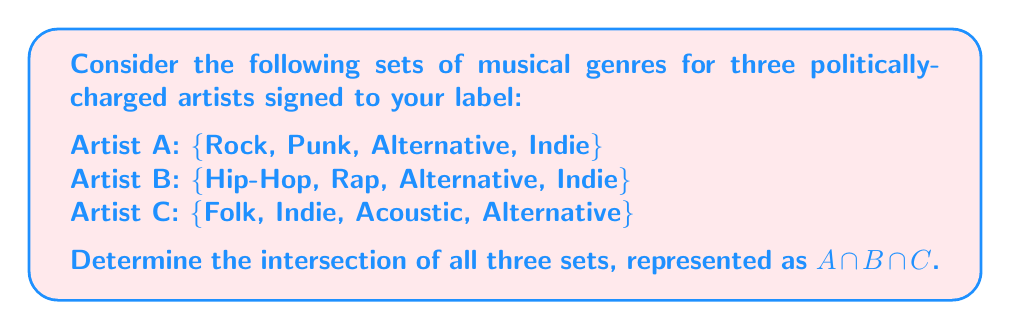Teach me how to tackle this problem. To find the intersection of all three sets, we need to identify the elements that are common to all three sets. Let's approach this step-by-step:

1. First, let's list out each set:
   Set A = $\{$Rock, Punk, Alternative, Indie$\}$
   Set B = $\{$Hip-Hop, Rap, Alternative, Indie$\}$
   Set C = $\{$Folk, Indie, Acoustic, Alternative$\}$

2. Now, we need to find elements that appear in all three sets. We can do this by comparing the elements:

   - "Rock" is only in Set A
   - "Punk" is only in Set A
   - "Hip-Hop" is only in Set B
   - "Rap" is only in Set B
   - "Folk" is only in Set C
   - "Acoustic" is only in Set C
   - "Alternative" appears in all three sets
   - "Indie" appears in all three sets

3. The intersection of all three sets, $A \cap B \cap C$, will contain only the elements that appear in all three sets.

Therefore, the intersection contains "Alternative" and "Indie".
Answer: $A \cap B \cap C = \{$Alternative, Indie$\}$ 